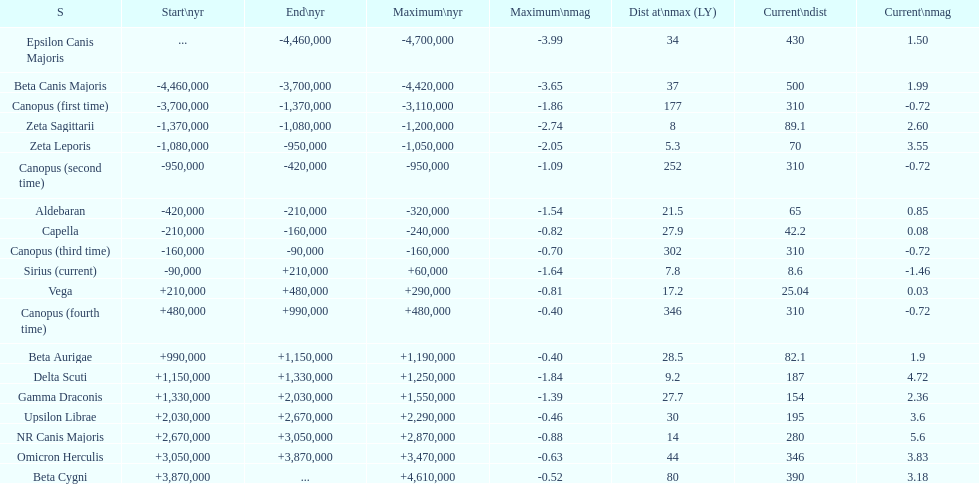Which star has the highest distance at maximum? Canopus (fourth time). 